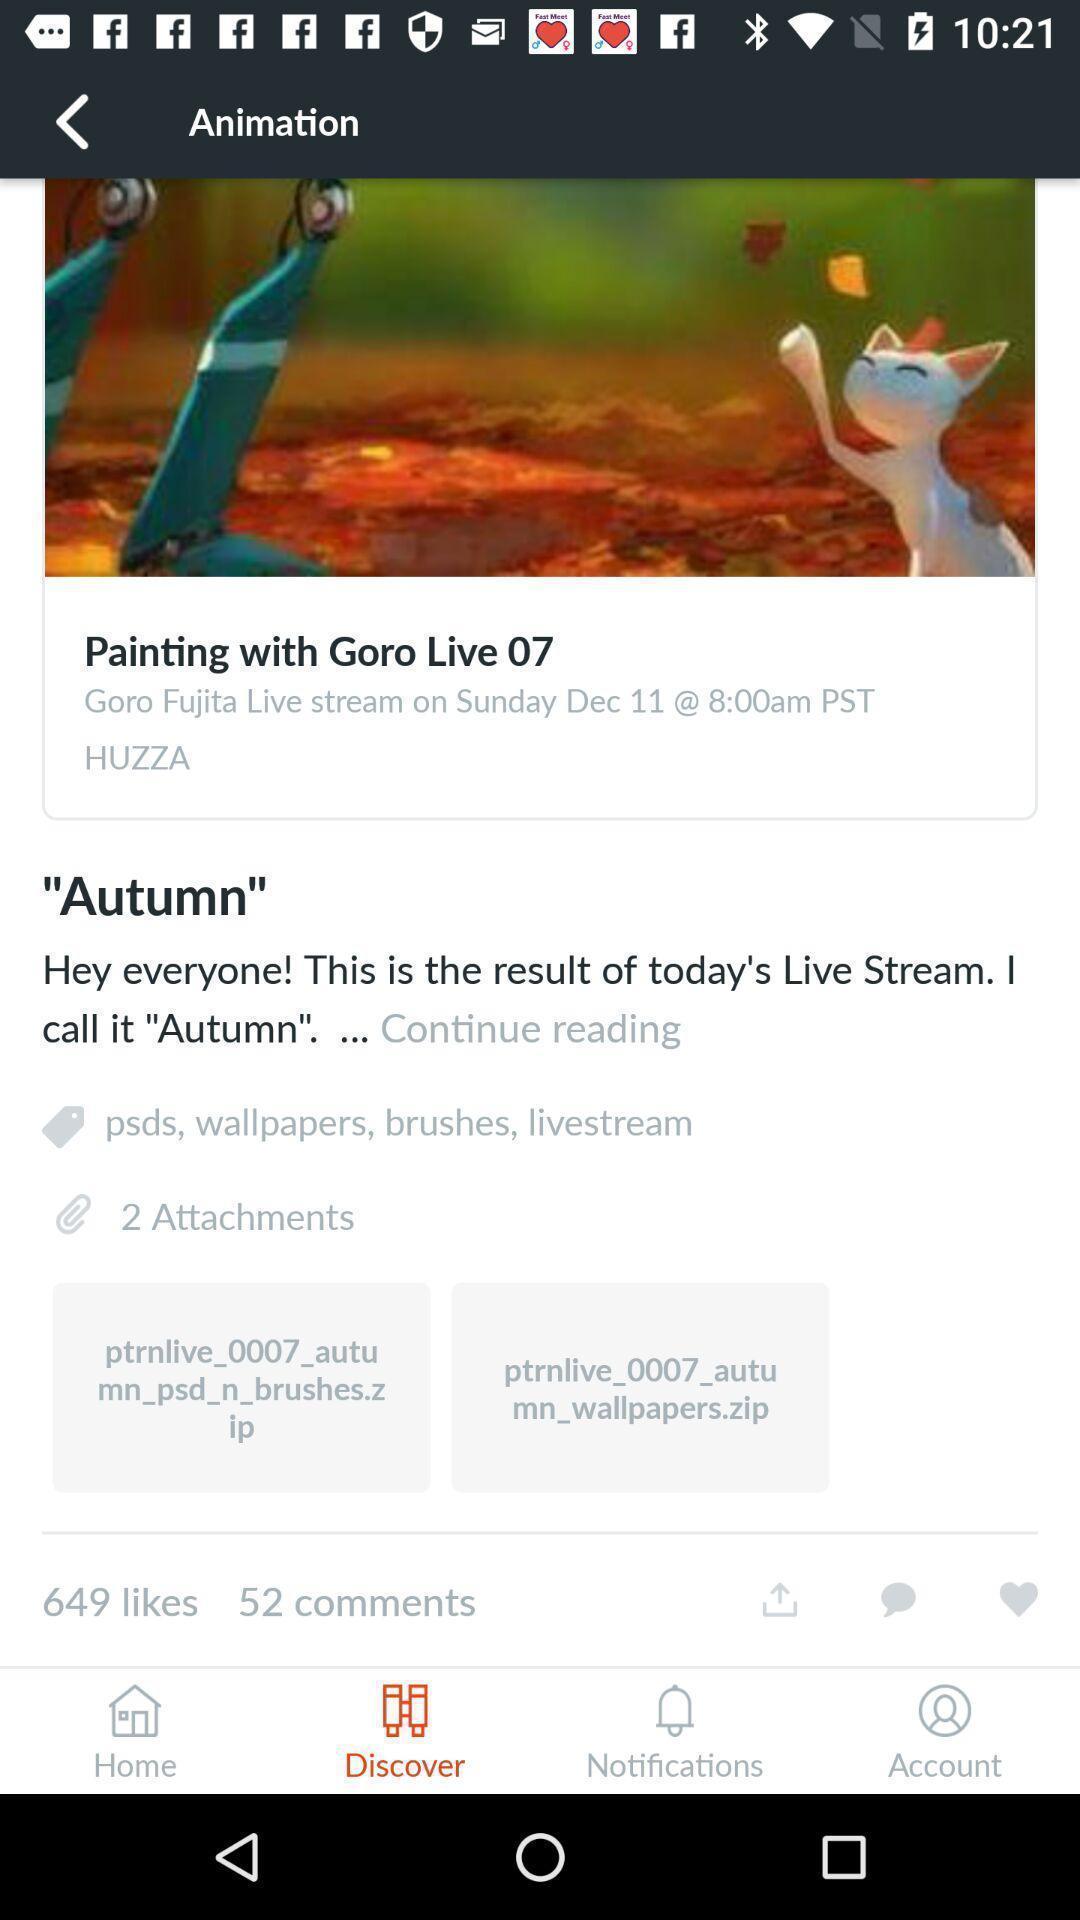Describe this image in words. Screen display discover page of an entertainment app. 